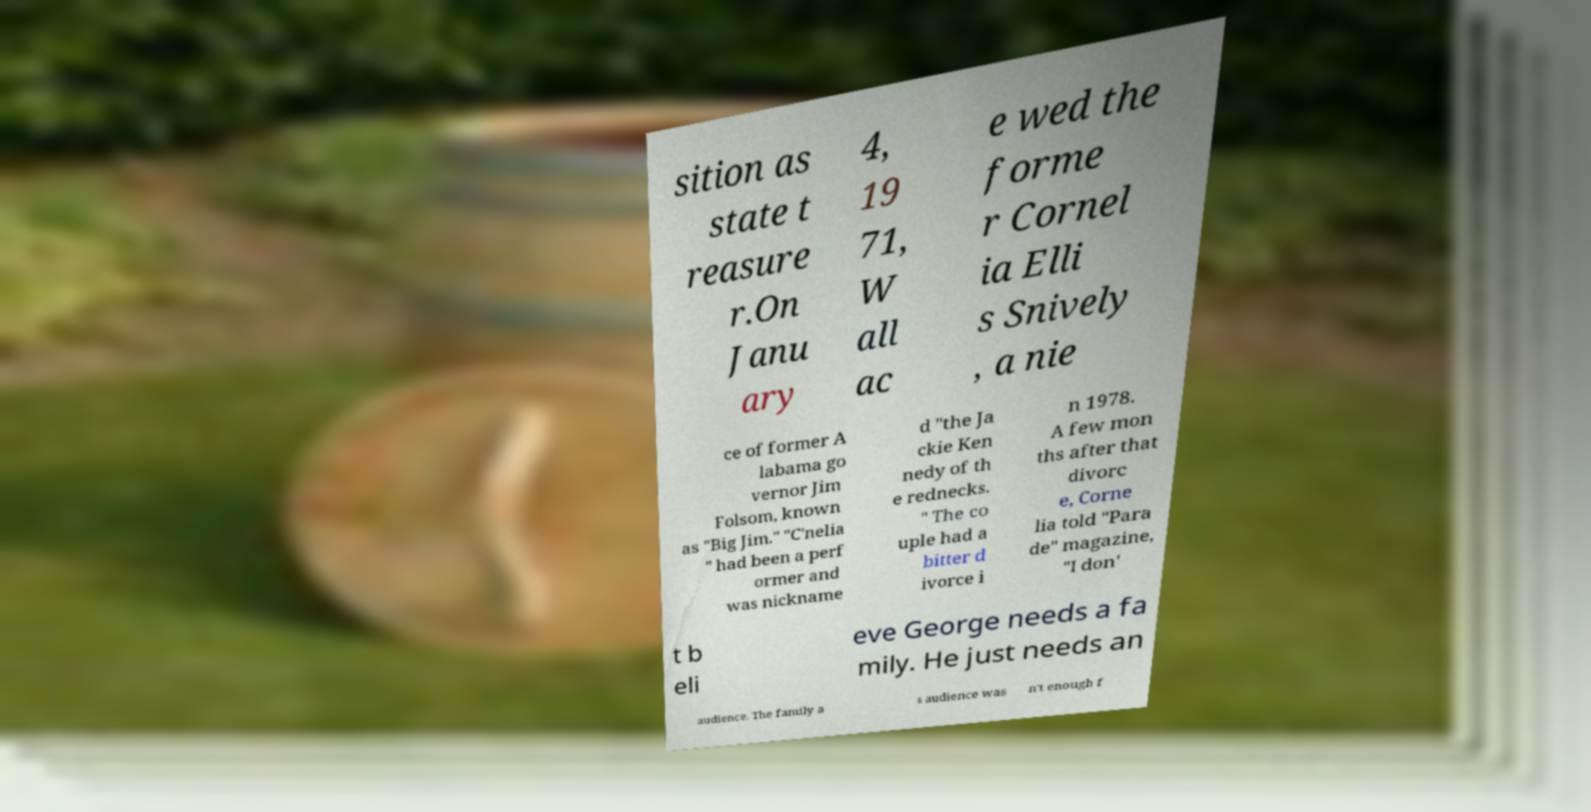I need the written content from this picture converted into text. Can you do that? sition as state t reasure r.On Janu ary 4, 19 71, W all ac e wed the forme r Cornel ia Elli s Snively , a nie ce of former A labama go vernor Jim Folsom, known as "Big Jim." "C'nelia " had been a perf ormer and was nickname d "the Ja ckie Ken nedy of th e rednecks. " The co uple had a bitter d ivorce i n 1978. A few mon ths after that divorc e, Corne lia told "Para de" magazine, "I don' t b eli eve George needs a fa mily. He just needs an audience. The family a s audience was n't enough f 